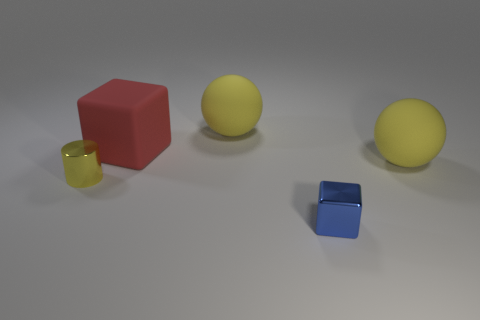Add 4 spheres. How many objects exist? 9 Subtract all cubes. How many objects are left? 3 Subtract 0 green balls. How many objects are left? 5 Subtract all big blue metal spheres. Subtract all big yellow things. How many objects are left? 3 Add 1 small yellow shiny cylinders. How many small yellow shiny cylinders are left? 2 Add 5 rubber spheres. How many rubber spheres exist? 7 